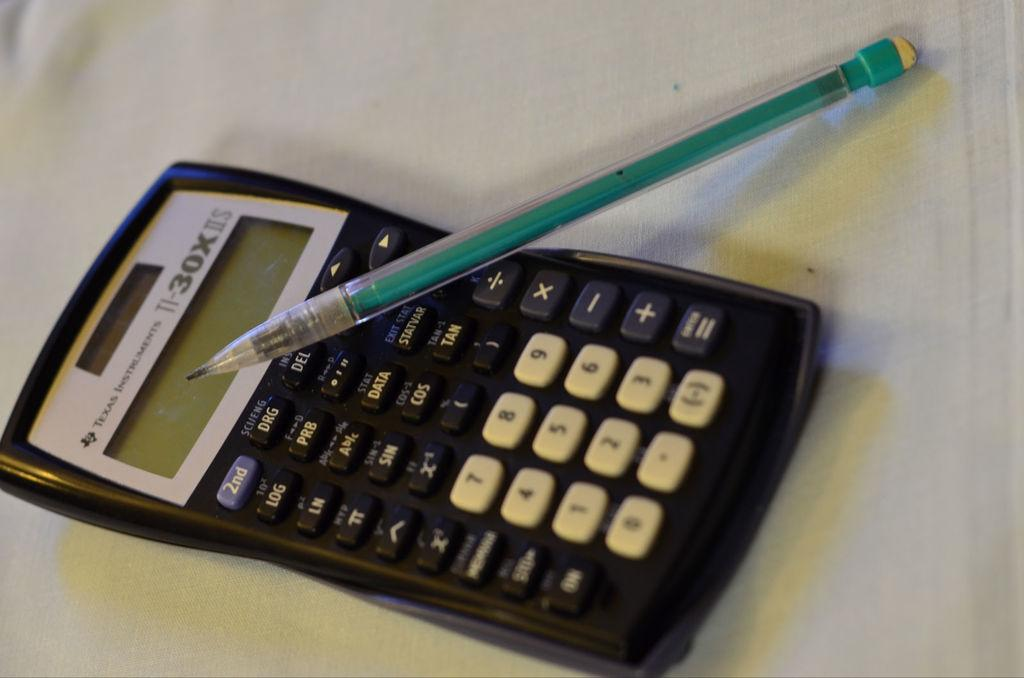<image>
Give a short and clear explanation of the subsequent image. A Texas Instruments calculator with a green pencil on it. 